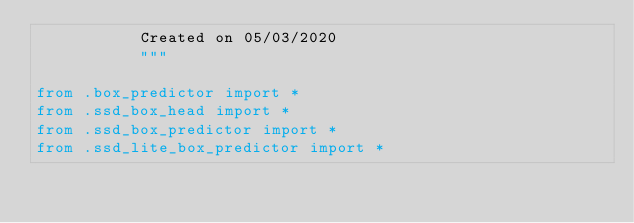Convert code to text. <code><loc_0><loc_0><loc_500><loc_500><_Python_>           Created on 05/03/2020
           """

from .box_predictor import *
from .ssd_box_head import *
from .ssd_box_predictor import *
from .ssd_lite_box_predictor import *
</code> 